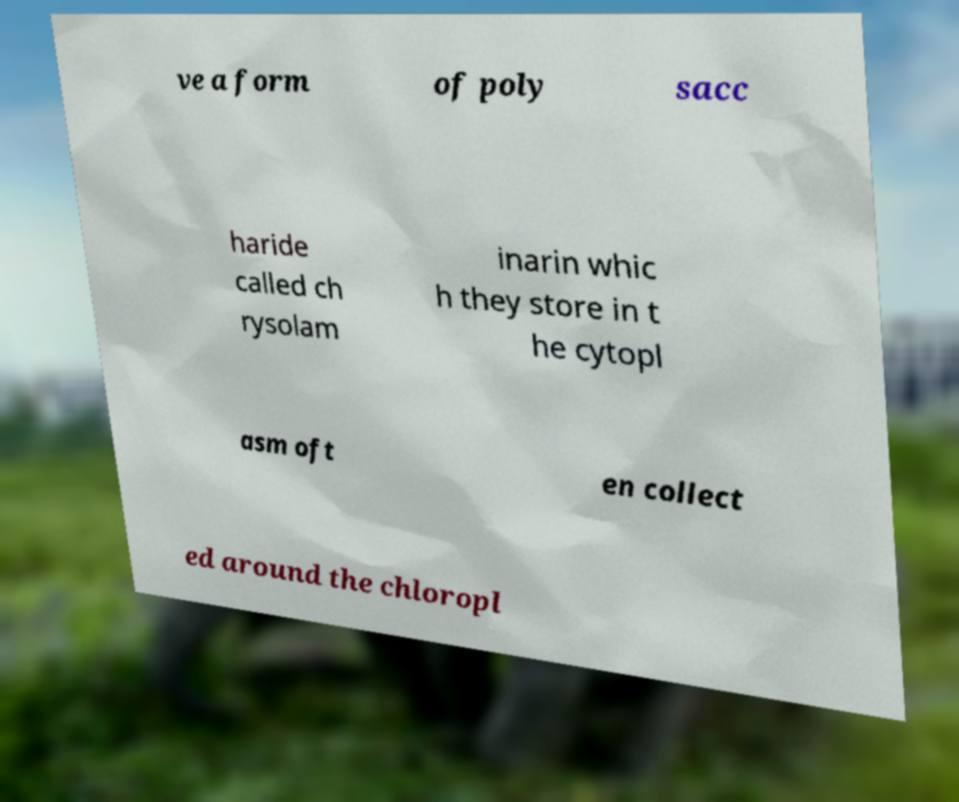Please identify and transcribe the text found in this image. ve a form of poly sacc haride called ch rysolam inarin whic h they store in t he cytopl asm oft en collect ed around the chloropl 